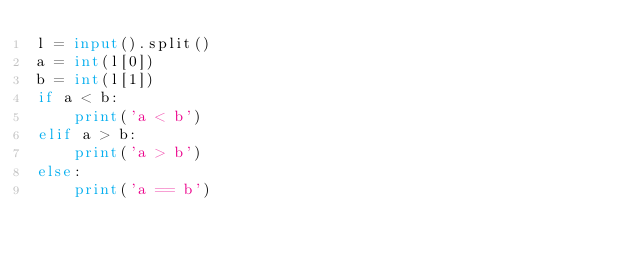<code> <loc_0><loc_0><loc_500><loc_500><_Python_>l = input().split()
a = int(l[0])
b = int(l[1])
if a < b:
    print('a < b')
elif a > b:
    print('a > b')
else:
    print('a == b')
</code> 